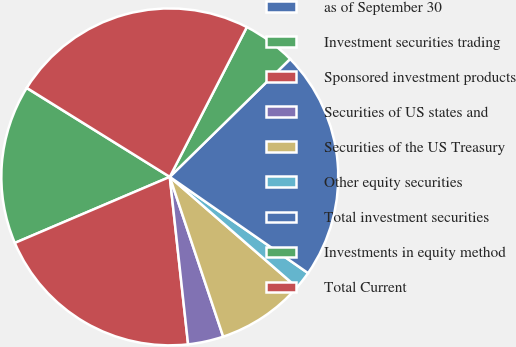Convert chart. <chart><loc_0><loc_0><loc_500><loc_500><pie_chart><fcel>as of September 30<fcel>Investment securities trading<fcel>Sponsored investment products<fcel>Securities of US states and<fcel>Securities of the US Treasury<fcel>Other equity securities<fcel>Total investment securities<fcel>Investments in equity method<fcel>Total Current<nl><fcel>0.02%<fcel>15.25%<fcel>20.32%<fcel>3.4%<fcel>8.48%<fcel>1.71%<fcel>22.01%<fcel>5.1%<fcel>23.7%<nl></chart> 